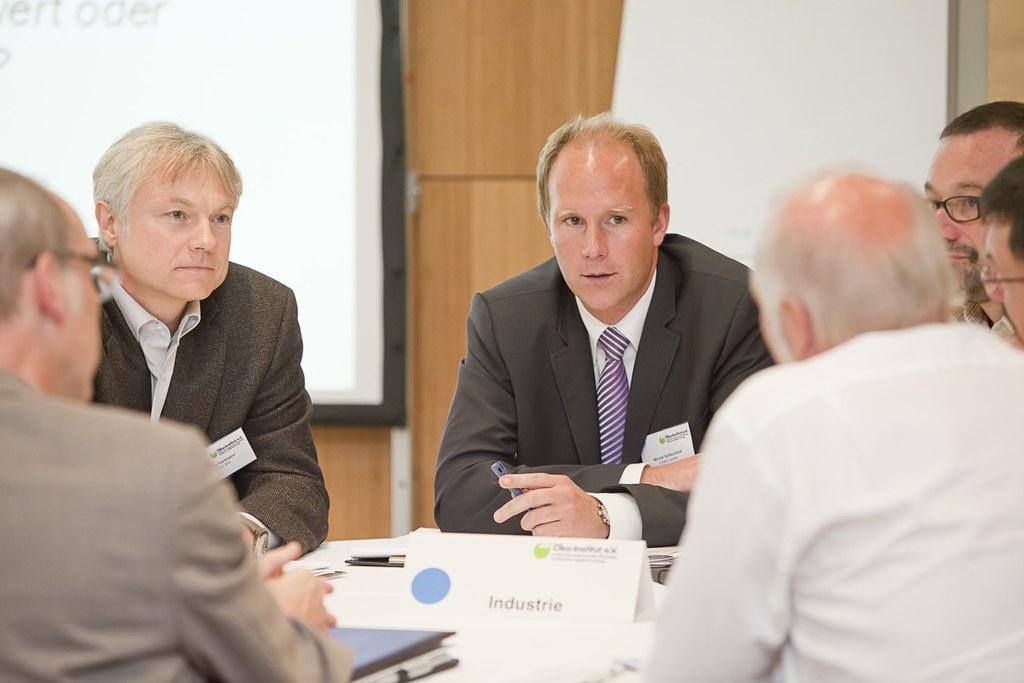How would you summarize this image in a sentence or two? In this picture, we see six men are sitting on the chairs. In front of them, we see a white table on which name board, book, papers and a pen are placed. Behind them, we see a white wall and a brown cupboard. On the left side, we see the projector screen which is displaying the text. 